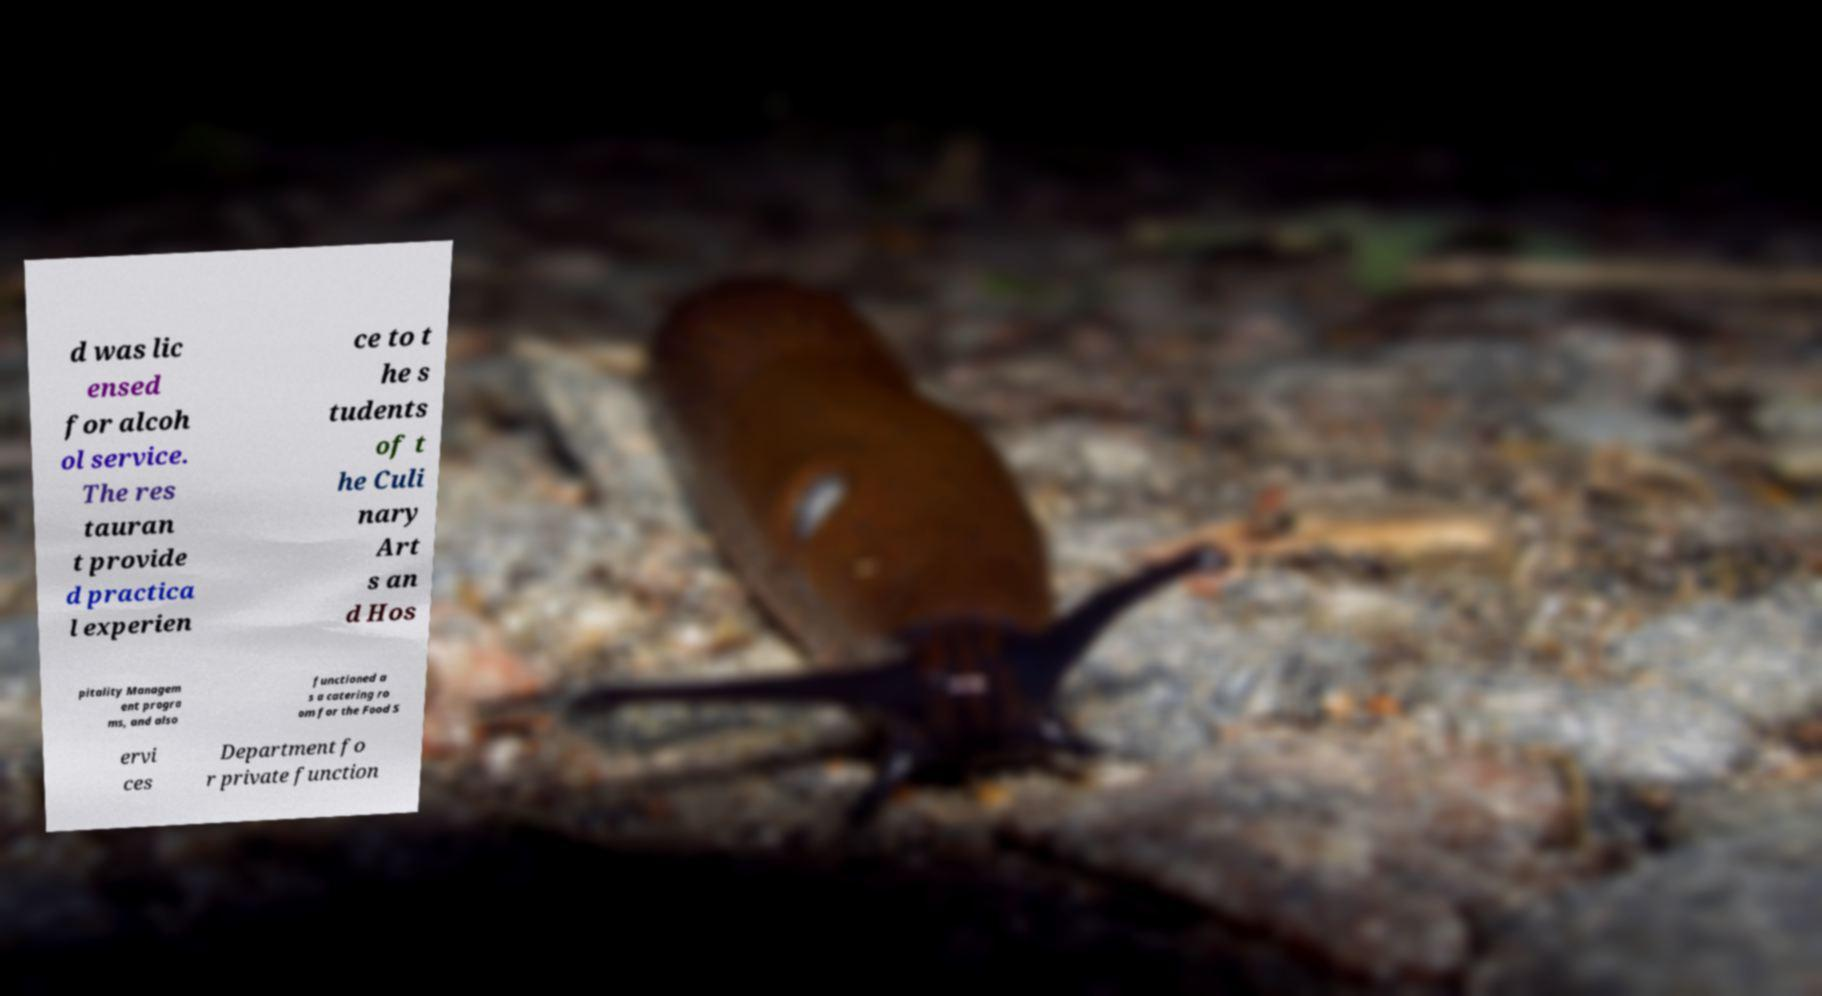There's text embedded in this image that I need extracted. Can you transcribe it verbatim? d was lic ensed for alcoh ol service. The res tauran t provide d practica l experien ce to t he s tudents of t he Culi nary Art s an d Hos pitality Managem ent progra ms, and also functioned a s a catering ro om for the Food S ervi ces Department fo r private function 